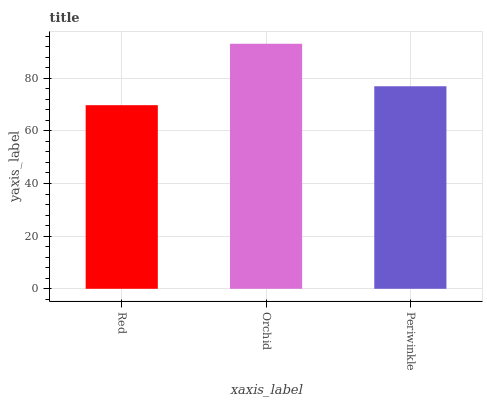Is Red the minimum?
Answer yes or no. Yes. Is Orchid the maximum?
Answer yes or no. Yes. Is Periwinkle the minimum?
Answer yes or no. No. Is Periwinkle the maximum?
Answer yes or no. No. Is Orchid greater than Periwinkle?
Answer yes or no. Yes. Is Periwinkle less than Orchid?
Answer yes or no. Yes. Is Periwinkle greater than Orchid?
Answer yes or no. No. Is Orchid less than Periwinkle?
Answer yes or no. No. Is Periwinkle the high median?
Answer yes or no. Yes. Is Periwinkle the low median?
Answer yes or no. Yes. Is Orchid the high median?
Answer yes or no. No. Is Red the low median?
Answer yes or no. No. 